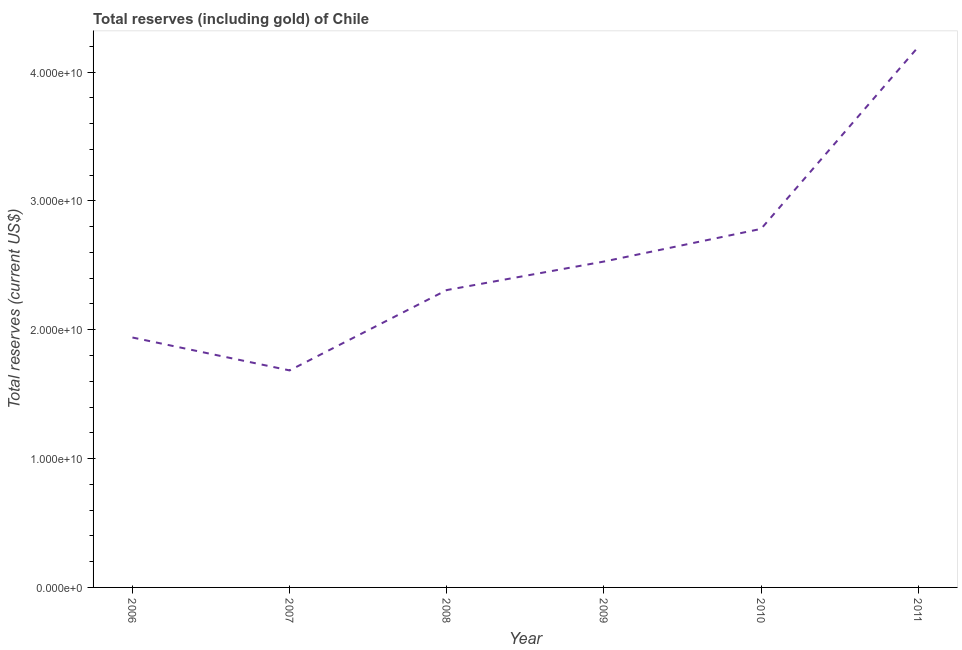What is the total reserves (including gold) in 2008?
Make the answer very short. 2.31e+1. Across all years, what is the maximum total reserves (including gold)?
Offer a terse response. 4.19e+1. Across all years, what is the minimum total reserves (including gold)?
Ensure brevity in your answer.  1.68e+1. In which year was the total reserves (including gold) maximum?
Offer a very short reply. 2011. What is the sum of the total reserves (including gold)?
Ensure brevity in your answer.  1.54e+11. What is the difference between the total reserves (including gold) in 2007 and 2009?
Give a very brief answer. -8.45e+09. What is the average total reserves (including gold) per year?
Your answer should be very brief. 2.57e+1. What is the median total reserves (including gold)?
Offer a terse response. 2.42e+1. Do a majority of the years between 2010 and 2008 (inclusive) have total reserves (including gold) greater than 36000000000 US$?
Give a very brief answer. No. What is the ratio of the total reserves (including gold) in 2008 to that in 2009?
Provide a succinct answer. 0.91. Is the total reserves (including gold) in 2006 less than that in 2010?
Ensure brevity in your answer.  Yes. Is the difference between the total reserves (including gold) in 2008 and 2009 greater than the difference between any two years?
Make the answer very short. No. What is the difference between the highest and the second highest total reserves (including gold)?
Your answer should be very brief. 1.41e+1. What is the difference between the highest and the lowest total reserves (including gold)?
Give a very brief answer. 2.51e+1. Are the values on the major ticks of Y-axis written in scientific E-notation?
Your response must be concise. Yes. Does the graph contain any zero values?
Make the answer very short. No. What is the title of the graph?
Your answer should be compact. Total reserves (including gold) of Chile. What is the label or title of the Y-axis?
Provide a short and direct response. Total reserves (current US$). What is the Total reserves (current US$) in 2006?
Provide a short and direct response. 1.94e+1. What is the Total reserves (current US$) of 2007?
Your answer should be compact. 1.68e+1. What is the Total reserves (current US$) of 2008?
Give a very brief answer. 2.31e+1. What is the Total reserves (current US$) in 2009?
Your response must be concise. 2.53e+1. What is the Total reserves (current US$) in 2010?
Offer a terse response. 2.78e+1. What is the Total reserves (current US$) of 2011?
Your answer should be very brief. 4.19e+1. What is the difference between the Total reserves (current US$) in 2006 and 2007?
Keep it short and to the point. 2.55e+09. What is the difference between the Total reserves (current US$) in 2006 and 2008?
Offer a very short reply. -3.68e+09. What is the difference between the Total reserves (current US$) in 2006 and 2009?
Offer a very short reply. -5.90e+09. What is the difference between the Total reserves (current US$) in 2006 and 2010?
Make the answer very short. -8.43e+09. What is the difference between the Total reserves (current US$) in 2006 and 2011?
Keep it short and to the point. -2.25e+1. What is the difference between the Total reserves (current US$) in 2007 and 2008?
Ensure brevity in your answer.  -6.24e+09. What is the difference between the Total reserves (current US$) in 2007 and 2009?
Provide a short and direct response. -8.45e+09. What is the difference between the Total reserves (current US$) in 2007 and 2010?
Your response must be concise. -1.10e+1. What is the difference between the Total reserves (current US$) in 2007 and 2011?
Your answer should be compact. -2.51e+1. What is the difference between the Total reserves (current US$) in 2008 and 2009?
Your response must be concise. -2.21e+09. What is the difference between the Total reserves (current US$) in 2008 and 2010?
Offer a very short reply. -4.75e+09. What is the difference between the Total reserves (current US$) in 2008 and 2011?
Your answer should be compact. -1.89e+1. What is the difference between the Total reserves (current US$) in 2009 and 2010?
Provide a short and direct response. -2.54e+09. What is the difference between the Total reserves (current US$) in 2009 and 2011?
Make the answer very short. -1.67e+1. What is the difference between the Total reserves (current US$) in 2010 and 2011?
Ensure brevity in your answer.  -1.41e+1. What is the ratio of the Total reserves (current US$) in 2006 to that in 2007?
Your answer should be compact. 1.15. What is the ratio of the Total reserves (current US$) in 2006 to that in 2008?
Ensure brevity in your answer.  0.84. What is the ratio of the Total reserves (current US$) in 2006 to that in 2009?
Provide a succinct answer. 0.77. What is the ratio of the Total reserves (current US$) in 2006 to that in 2010?
Offer a terse response. 0.7. What is the ratio of the Total reserves (current US$) in 2006 to that in 2011?
Give a very brief answer. 0.46. What is the ratio of the Total reserves (current US$) in 2007 to that in 2008?
Your answer should be compact. 0.73. What is the ratio of the Total reserves (current US$) in 2007 to that in 2009?
Offer a terse response. 0.67. What is the ratio of the Total reserves (current US$) in 2007 to that in 2010?
Ensure brevity in your answer.  0.6. What is the ratio of the Total reserves (current US$) in 2007 to that in 2011?
Provide a short and direct response. 0.4. What is the ratio of the Total reserves (current US$) in 2008 to that in 2009?
Provide a succinct answer. 0.91. What is the ratio of the Total reserves (current US$) in 2008 to that in 2010?
Your response must be concise. 0.83. What is the ratio of the Total reserves (current US$) in 2008 to that in 2011?
Provide a short and direct response. 0.55. What is the ratio of the Total reserves (current US$) in 2009 to that in 2010?
Provide a short and direct response. 0.91. What is the ratio of the Total reserves (current US$) in 2009 to that in 2011?
Provide a short and direct response. 0.6. What is the ratio of the Total reserves (current US$) in 2010 to that in 2011?
Offer a very short reply. 0.66. 